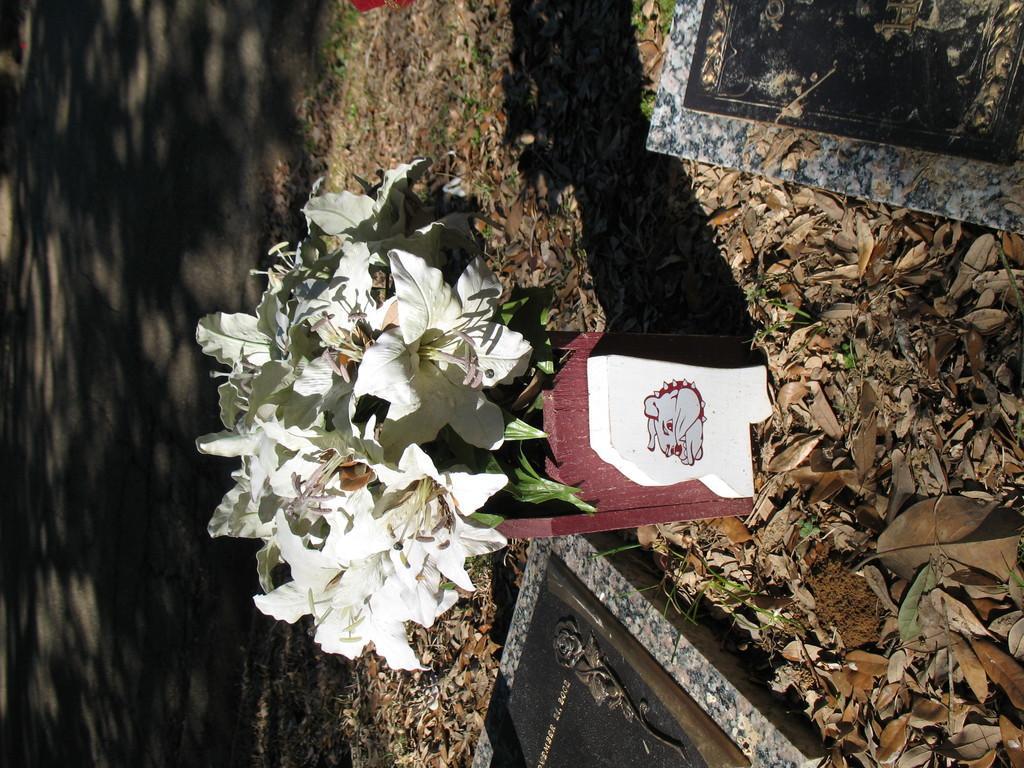In one or two sentences, can you explain what this image depicts? In the image there is a potted plant and around that there are many dry leaves and two marble stones. In the background there is a road. 